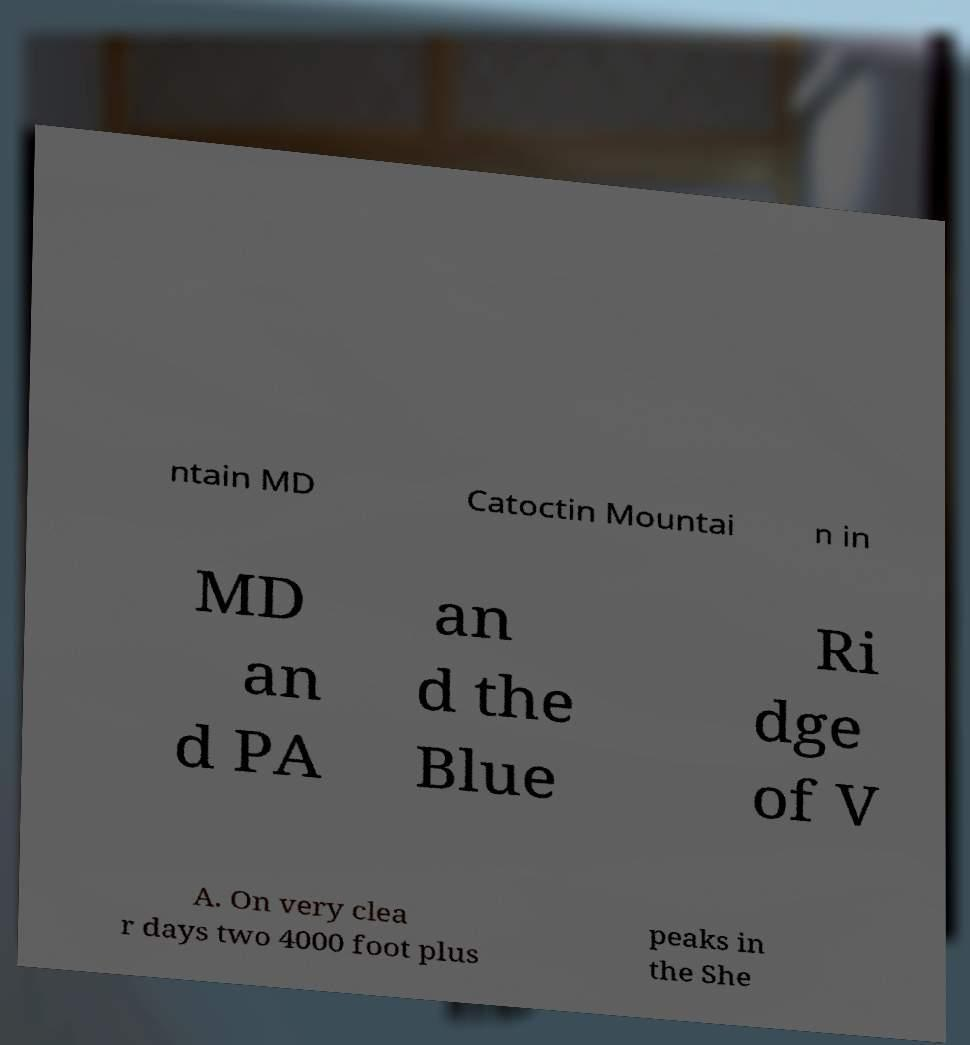Could you extract and type out the text from this image? ntain MD Catoctin Mountai n in MD an d PA an d the Blue Ri dge of V A. On very clea r days two 4000 foot plus peaks in the She 